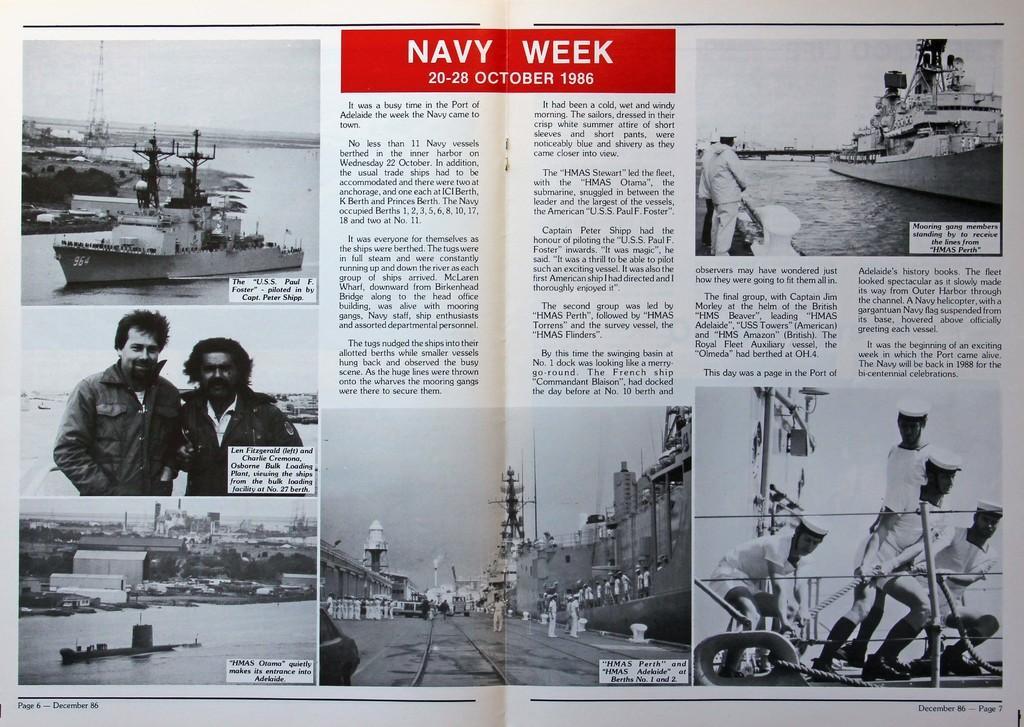How would you summarize this image in a sentence or two? In the picture it looks like a middle page of a book and there are some pictures related to the navy and in the middle there is some description about the pictures. 